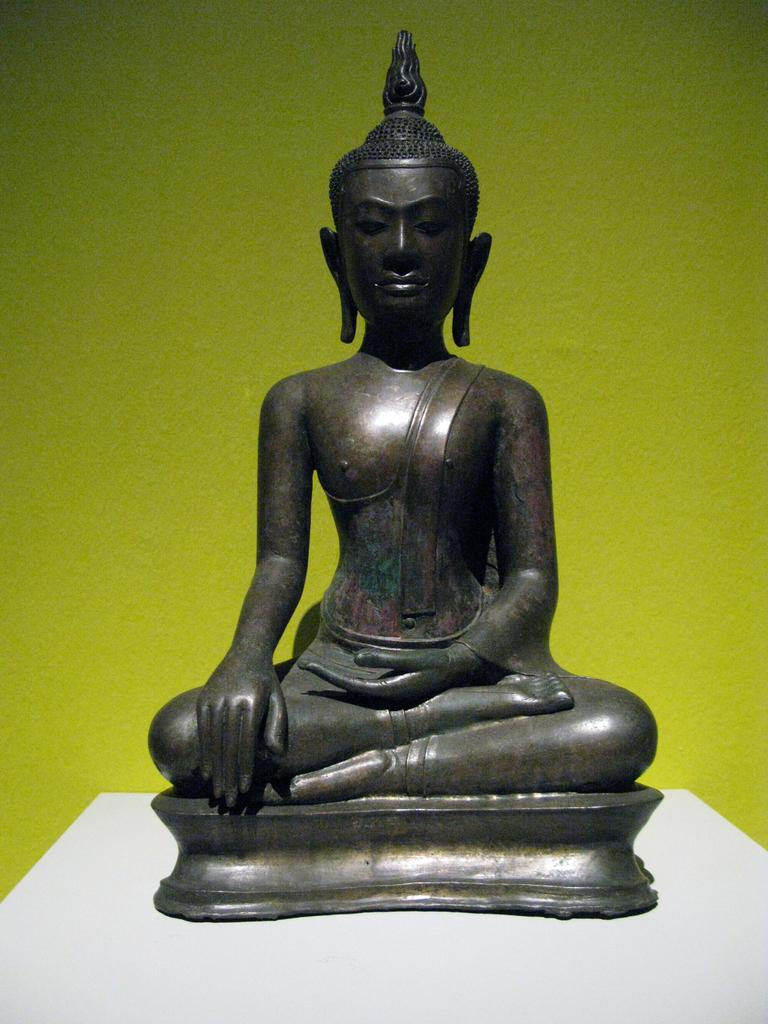What is the main subject of the image? There is a statue on a stand in the image. Can you describe the background of the image? There is a yellow wall in the background of the image. What type of company is depicted on the vase in the image? There is no vase present in the image, and therefore no company can be depicted on it. How many bricks are visible in the image? The image does not show any bricks; it features a statue on a stand and a yellow wall in the background. 